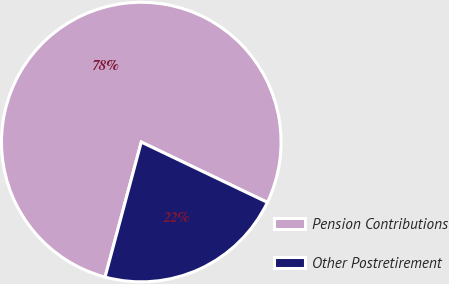Convert chart to OTSL. <chart><loc_0><loc_0><loc_500><loc_500><pie_chart><fcel>Pension Contributions<fcel>Other Postretirement<nl><fcel>77.93%<fcel>22.07%<nl></chart> 